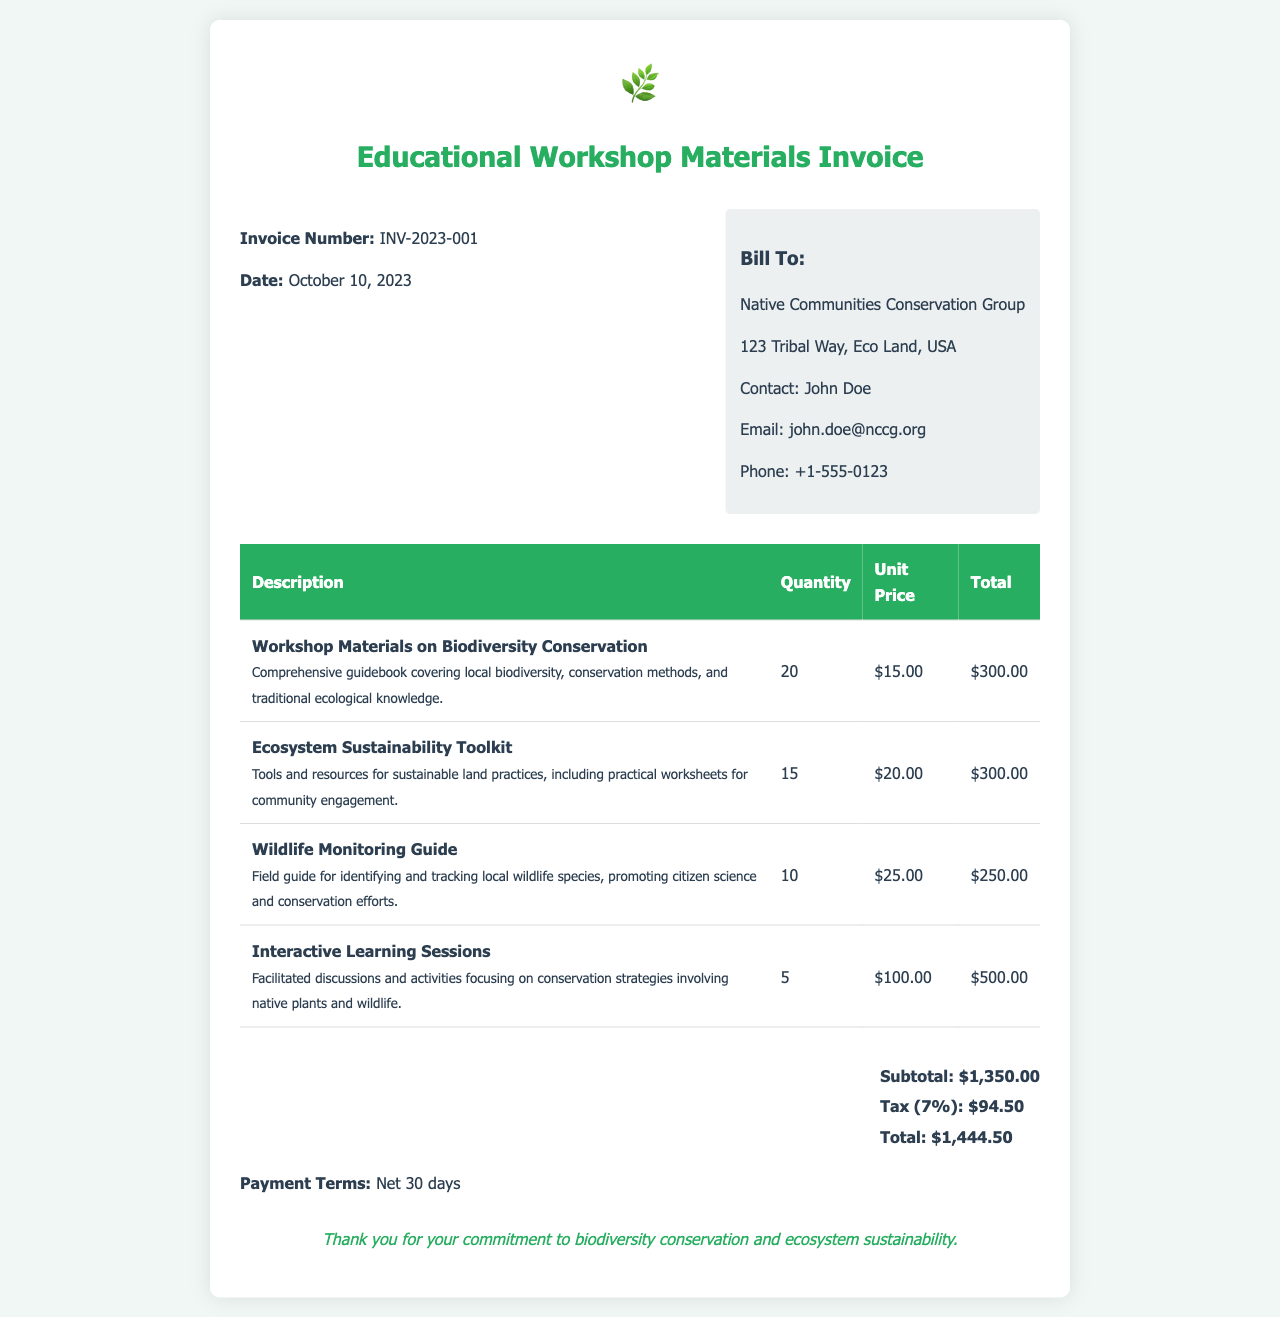What is the invoice number? The invoice number is listed at the top of the document, specifically identified as INV-2023-001.
Answer: INV-2023-001 What is the date of the invoice? The date of the invoice is provided in the header section as October 10, 2023.
Answer: October 10, 2023 Who is the contact person for the bill? The contact person is mentioned in the billing section as John Doe.
Answer: John Doe What is the subtotal amount? The subtotal amount is detailed in the total section of the document and is stated as $1,350.00.
Answer: $1,350.00 How many units of the Wildlife Monitoring Guide were ordered? The quantity of the Wildlife Monitoring Guide is listed in the table, which shows 10 units ordered.
Answer: 10 What is the total amount after tax? The total amount after tax is calculated in the total section of the document, which includes the subtotal and tax, amounting to $1,444.50.
Answer: $1,444.50 What percentage is the tax applied to the subtotal? The tax mentioned in the invoice is stated as 7% of the subtotal amount.
Answer: 7% What type of document is this? This document is specifically identified as an invoice for educational workshop materials.
Answer: Invoice How many different workshop materials are listed? The invoice lists four different types of workshop materials corresponding to educational content.
Answer: 4 